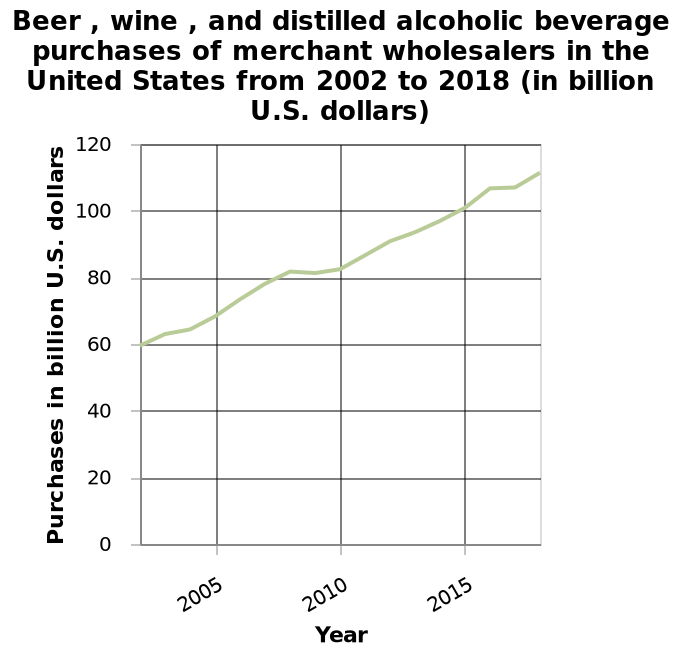<image>
please enumerates aspects of the construction of the chart Here a line diagram is called Beer , wine , and distilled alcoholic beverage purchases of merchant wholesalers in the United States from 2002 to 2018 (in billion U.S. dollars). A linear scale from 2005 to 2015 can be seen on the x-axis, labeled Year. Purchases in billion U.S. dollars is defined as a linear scale of range 0 to 120 along the y-axis. In which period did the increase in alcohol purchases between 2002 and 2015 slow down?  The increase in alcohol purchases slowed down between 2005 and 2010. Which period experienced the largest increase in alcohol purchases between 2010 and 2015? The largest increase occurred between 2010 and 2015, amounting to 20 billion dollars. 